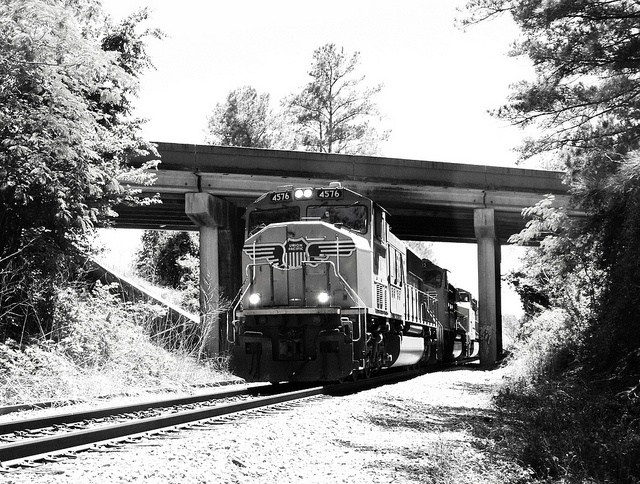Describe the objects in this image and their specific colors. I can see a train in darkgray, black, gray, and lightgray tones in this image. 